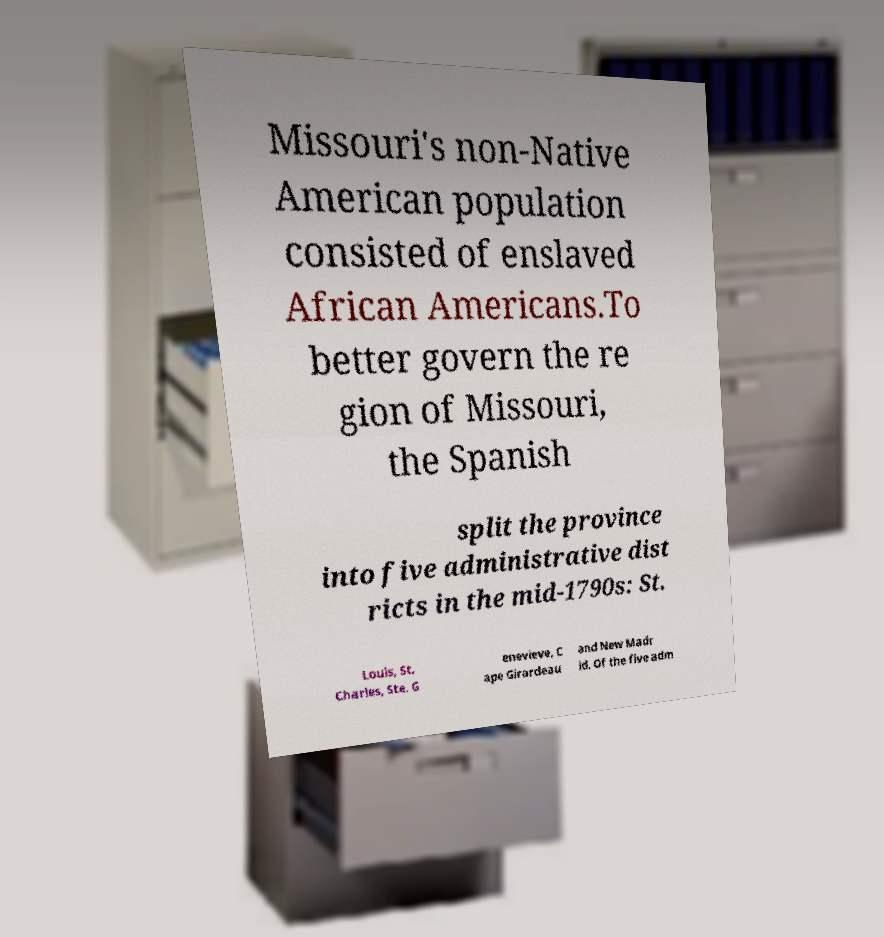There's text embedded in this image that I need extracted. Can you transcribe it verbatim? Missouri's non-Native American population consisted of enslaved African Americans.To better govern the re gion of Missouri, the Spanish split the province into five administrative dist ricts in the mid-1790s: St. Louis, St. Charles, Ste. G enevieve, C ape Girardeau and New Madr id. Of the five adm 